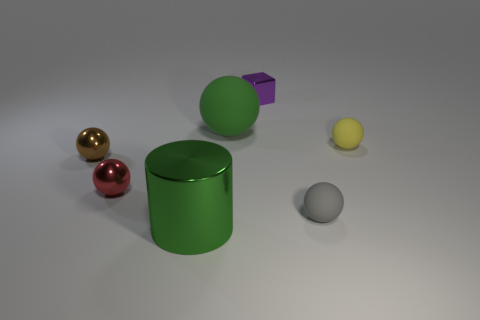How many things are either small spheres right of the tiny gray sphere or large objects on the left side of the green rubber object?
Your answer should be compact. 2. The yellow sphere that is the same material as the gray object is what size?
Offer a very short reply. Small. How many rubber things are either cubes or tiny cyan blocks?
Give a very brief answer. 0. What is the size of the shiny cylinder?
Give a very brief answer. Large. Is the gray thing the same size as the green ball?
Make the answer very short. No. There is a green thing that is in front of the tiny gray thing; what material is it?
Provide a short and direct response. Metal. There is a red thing that is the same shape as the gray rubber object; what material is it?
Offer a terse response. Metal. There is a rubber sphere behind the yellow matte ball; are there any small spheres that are in front of it?
Provide a succinct answer. Yes. Is the green shiny object the same shape as the tiny yellow thing?
Provide a short and direct response. No. What is the shape of the red object that is the same material as the brown thing?
Offer a terse response. Sphere. 